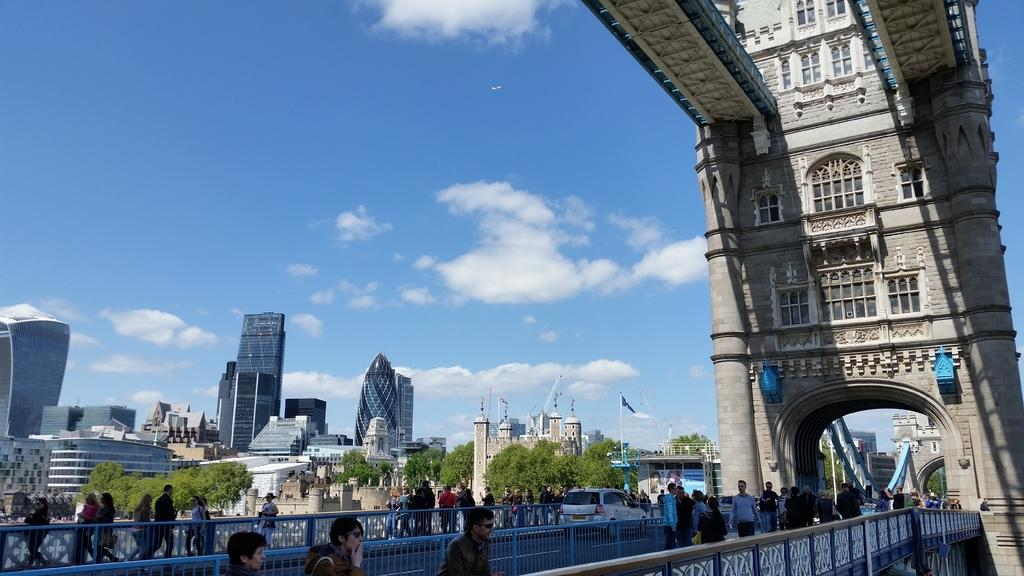What type of structure is in the image? There is a tower bridge in the image. Are there any people in the image? Yes, there is a group of people in the image. What else can be seen in the image besides the tower bridge and people? There is a car, buildings, trees, a flag with a pole, and the sky visible in the background of the image. What type of alarm is ringing in the image? There is no alarm present in the image. Can you compare the size of the trees to the buildings in the image? While we can see the trees and buildings in the image, we cannot make a comparison of their sizes based on the provided facts. 